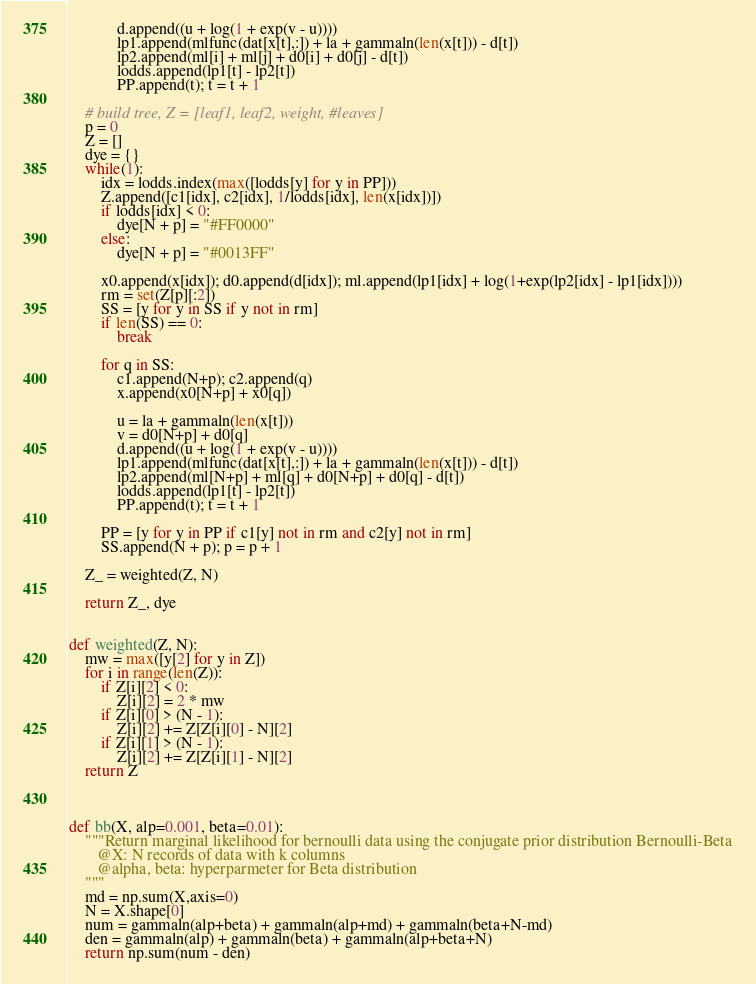Convert code to text. <code><loc_0><loc_0><loc_500><loc_500><_Python_>            d.append((u + log(1 + exp(v - u))))
            lp1.append(mlfunc(dat[x[t],:]) + la + gammaln(len(x[t])) - d[t])
            lp2.append(ml[i] + ml[j] + d0[i] + d0[j] - d[t])
            lodds.append(lp1[t] - lp2[t])
            PP.append(t); t = t + 1

    # build tree, Z = [leaf1, leaf2, weight, #leaves]
    p = 0
    Z = []
    dye = {}
    while(1):
        idx = lodds.index(max([lodds[y] for y in PP]))
        Z.append([c1[idx], c2[idx], 1/lodds[idx], len(x[idx])])
        if lodds[idx] < 0:
            dye[N + p] = "#FF0000"
        else:
            dye[N + p] = "#0013FF"

        x0.append(x[idx]); d0.append(d[idx]); ml.append(lp1[idx] + log(1+exp(lp2[idx] - lp1[idx])))
        rm = set(Z[p][:2])
        SS = [y for y in SS if y not in rm]
        if len(SS) == 0:
            break

        for q in SS:
            c1.append(N+p); c2.append(q)
            x.append(x0[N+p] + x0[q])

            u = la + gammaln(len(x[t]))
            v = d0[N+p] + d0[q]
            d.append((u + log(1 + exp(v - u))))
            lp1.append(mlfunc(dat[x[t],:]) + la + gammaln(len(x[t])) - d[t])
            lp2.append(ml[N+p] + ml[q] + d0[N+p] + d0[q] - d[t])
            lodds.append(lp1[t] - lp2[t])
            PP.append(t); t = t + 1

        PP = [y for y in PP if c1[y] not in rm and c2[y] not in rm]
        SS.append(N + p); p = p + 1

    Z_ = weighted(Z, N)

    return Z_, dye


def weighted(Z, N):
    mw = max([y[2] for y in Z])
    for i in range(len(Z)):
        if Z[i][2] < 0:
            Z[i][2] = 2 * mw
        if Z[i][0] > (N - 1):
            Z[i][2] += Z[Z[i][0] - N][2]
        if Z[i][1] > (N - 1):
            Z[i][2] += Z[Z[i][1] - N][2]
    return Z



def bb(X, alp=0.001, beta=0.01):
    """Return marginal likelihood for bernoulli data using the conjugate prior distribution Bernoulli-Beta
       @X: N records of data with k columns
       @alpha, beta: hyperparmeter for Beta distribution
    """
    md = np.sum(X,axis=0)
    N = X.shape[0]
    num = gammaln(alp+beta) + gammaln(alp+md) + gammaln(beta+N-md)
    den = gammaln(alp) + gammaln(beta) + gammaln(alp+beta+N)
    return np.sum(num - den)
</code> 